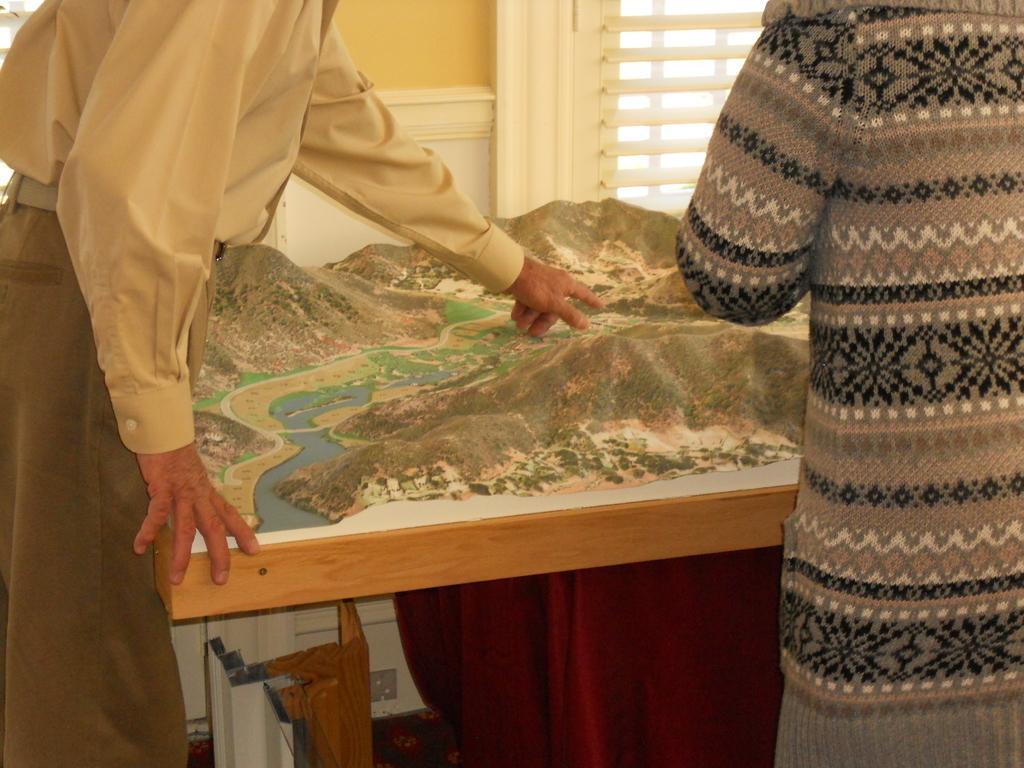In one or two sentences, can you explain what this image depicts? In the middle of the image there is a table on which there is a cloth. Under the table there are few objects on the floor. On the right side there is a person wearing a jacket and standing facing towards the back side. On the left side there is a man standing and pointing out at the cloth which is on the table. In the background there is a window. 